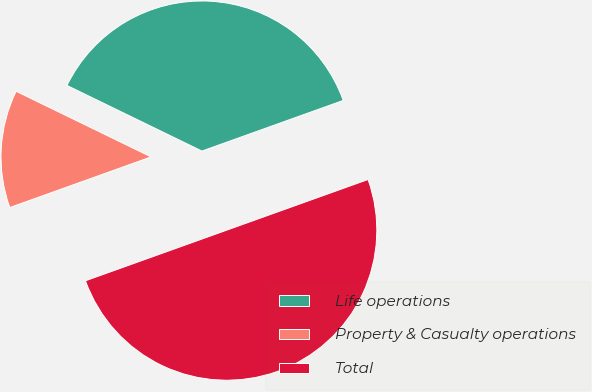<chart> <loc_0><loc_0><loc_500><loc_500><pie_chart><fcel>Life operations<fcel>Property & Casualty operations<fcel>Total<nl><fcel>37.32%<fcel>12.68%<fcel>50.0%<nl></chart> 